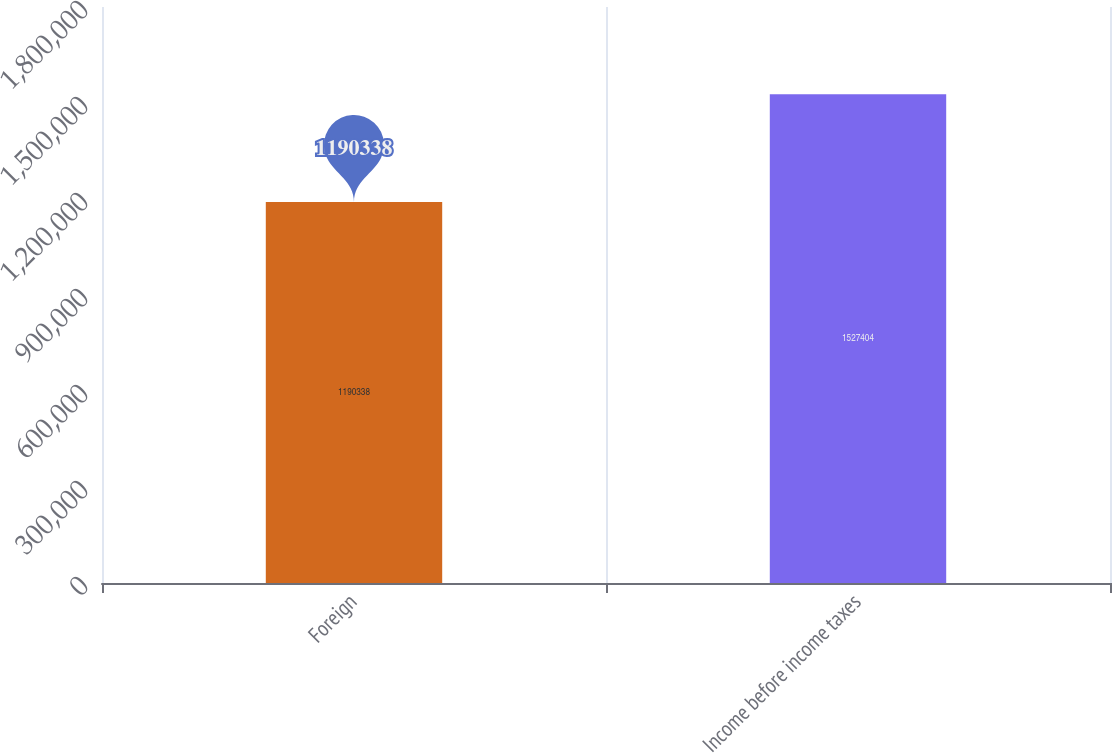<chart> <loc_0><loc_0><loc_500><loc_500><bar_chart><fcel>Foreign<fcel>Income before income taxes<nl><fcel>1.19034e+06<fcel>1.5274e+06<nl></chart> 